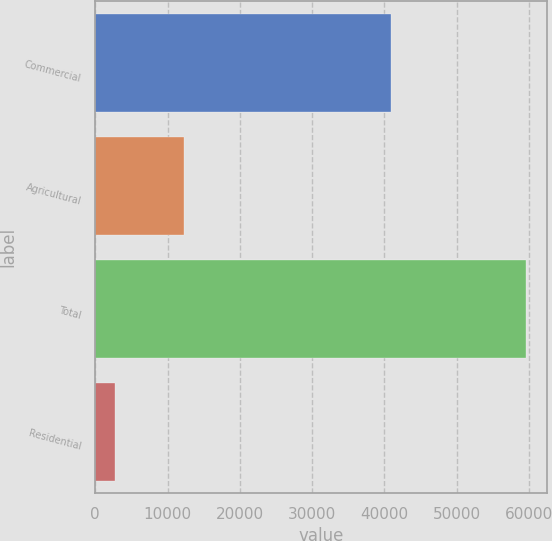Convert chart to OTSL. <chart><loc_0><loc_0><loc_500><loc_500><bar_chart><fcel>Commercial<fcel>Agricultural<fcel>Total<fcel>Residential<nl><fcel>40913<fcel>12317<fcel>59562<fcel>2756<nl></chart> 